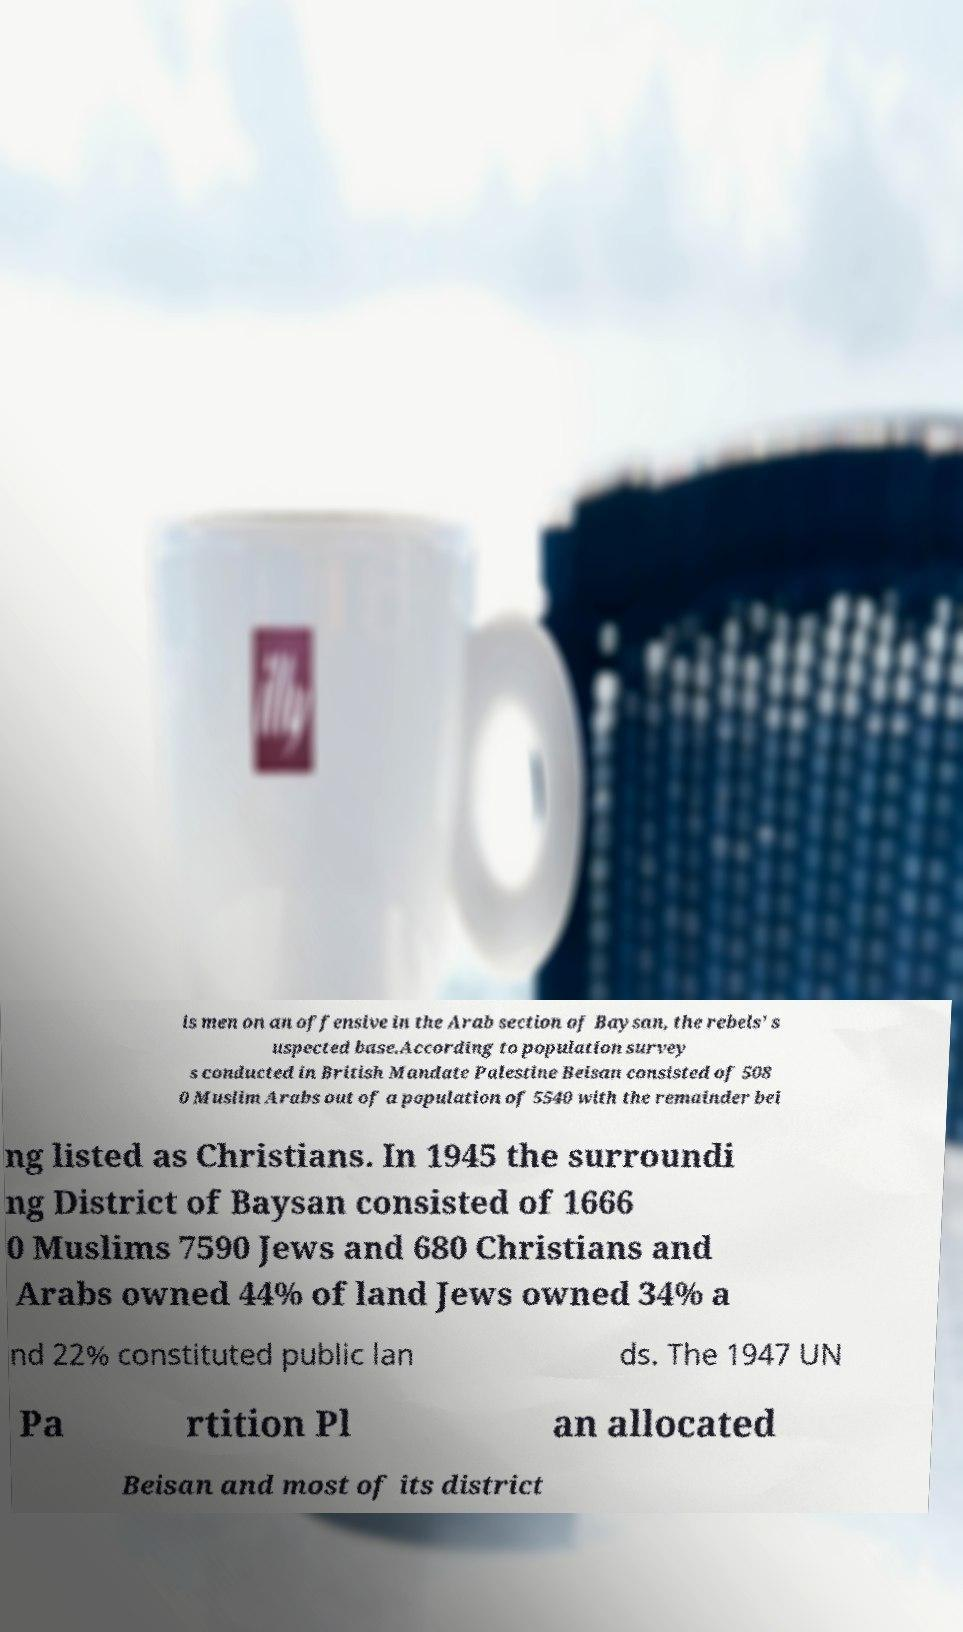There's text embedded in this image that I need extracted. Can you transcribe it verbatim? is men on an offensive in the Arab section of Baysan, the rebels’ s uspected base.According to population survey s conducted in British Mandate Palestine Beisan consisted of 508 0 Muslim Arabs out of a population of 5540 with the remainder bei ng listed as Christians. In 1945 the surroundi ng District of Baysan consisted of 1666 0 Muslims 7590 Jews and 680 Christians and Arabs owned 44% of land Jews owned 34% a nd 22% constituted public lan ds. The 1947 UN Pa rtition Pl an allocated Beisan and most of its district 